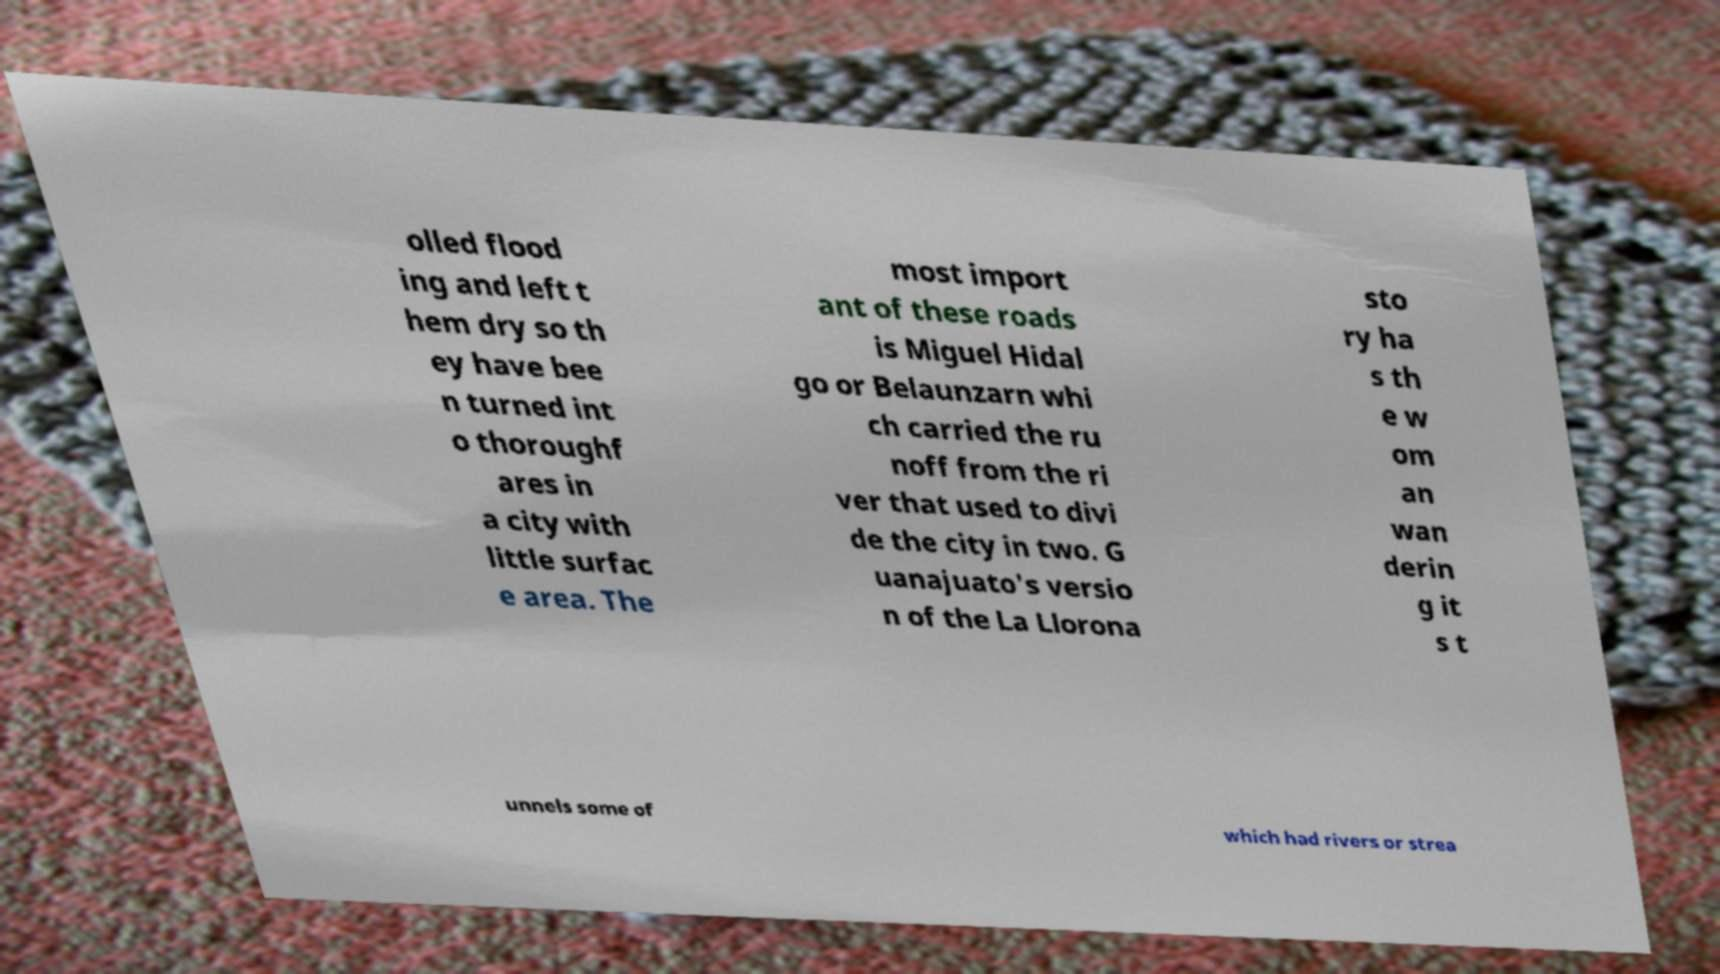What messages or text are displayed in this image? I need them in a readable, typed format. olled flood ing and left t hem dry so th ey have bee n turned int o thoroughf ares in a city with little surfac e area. The most import ant of these roads is Miguel Hidal go or Belaunzarn whi ch carried the ru noff from the ri ver that used to divi de the city in two. G uanajuato's versio n of the La Llorona sto ry ha s th e w om an wan derin g it s t unnels some of which had rivers or strea 